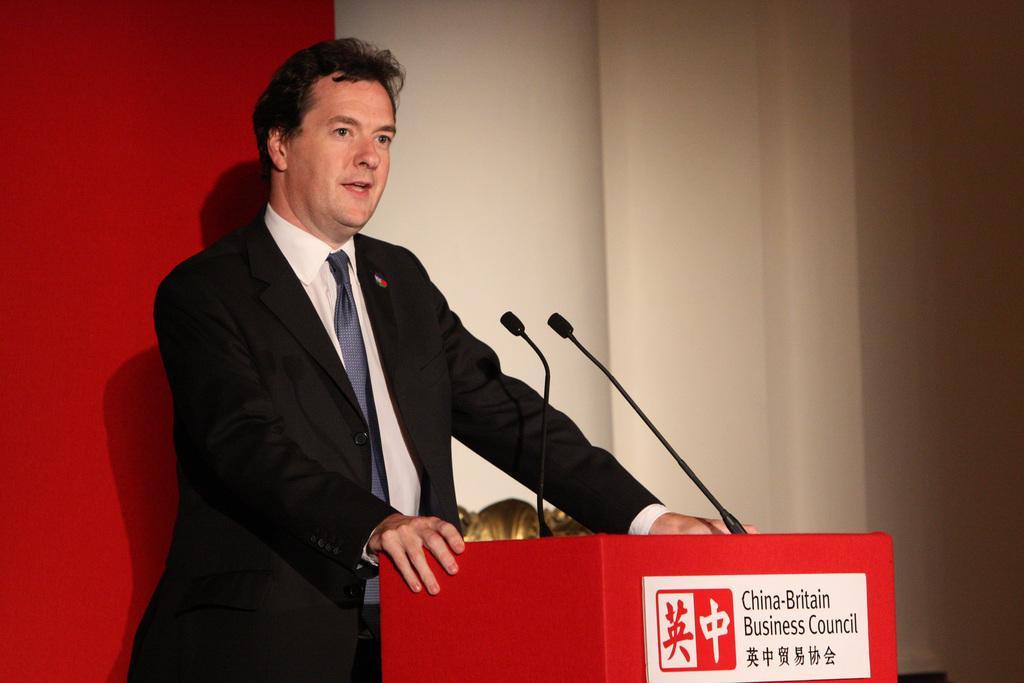Could you give a brief overview of what you see in this image? In the center of the image there is a person near a podium. He is wearing a suit. In the background of the image there is wall. 